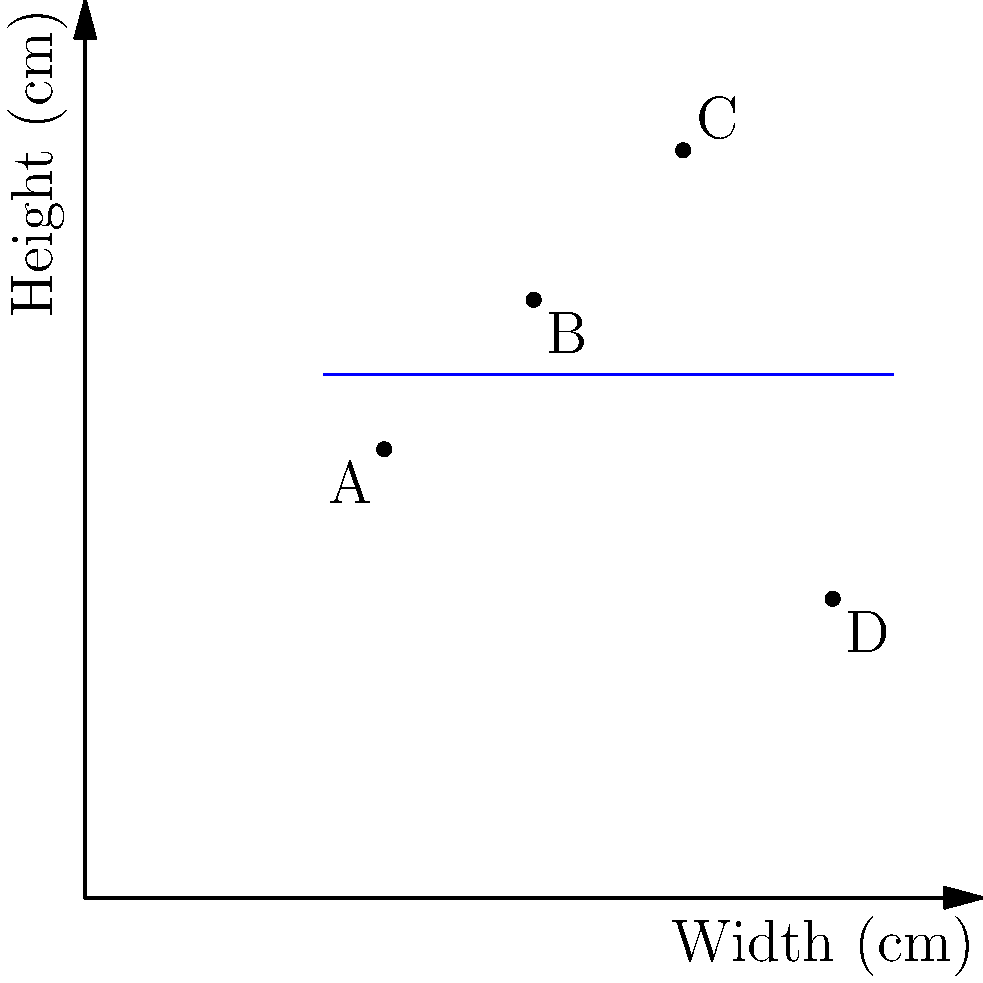You're organizing a bookshelf and decide to analyze the relationship between book width and height. The graph shows four books (A, B, C, and D) plotted based on their width and height in centimeters. What type of correlation, if any, exists between the width and height of these books? To determine the correlation between book width and height, let's follow these steps:

1. Understand correlation:
   - Positive correlation: As one variable increases, the other tends to increase.
   - Negative correlation: As one variable increases, the other tends to decrease.
   - No correlation: There's no clear pattern between the variables.

2. Analyze the data points:
   - Book A: (10 cm width, 15 cm height)
   - Book B: (15 cm width, 20 cm height)
   - Book C: (20 cm width, 25 cm height)
   - Book D: (25 cm width, 10 cm height)

3. Look for a pattern:
   - From A to C, there seems to be a positive correlation (width and height both increase).
   - However, D breaks this pattern significantly (widest book, but shortest height).

4. Consider the line of best fit:
   - The blue line represents an approximation of the overall trend.
   - It's nearly horizontal, suggesting little to no correlation.

5. Conclusion:
   - The data points don't show a consistent pattern.
   - The presence of D significantly affects any potential correlation.
   - The horizontal line of best fit indicates no clear relationship between width and height.

Therefore, there is no clear correlation between the width and height of these books.
Answer: No correlation 